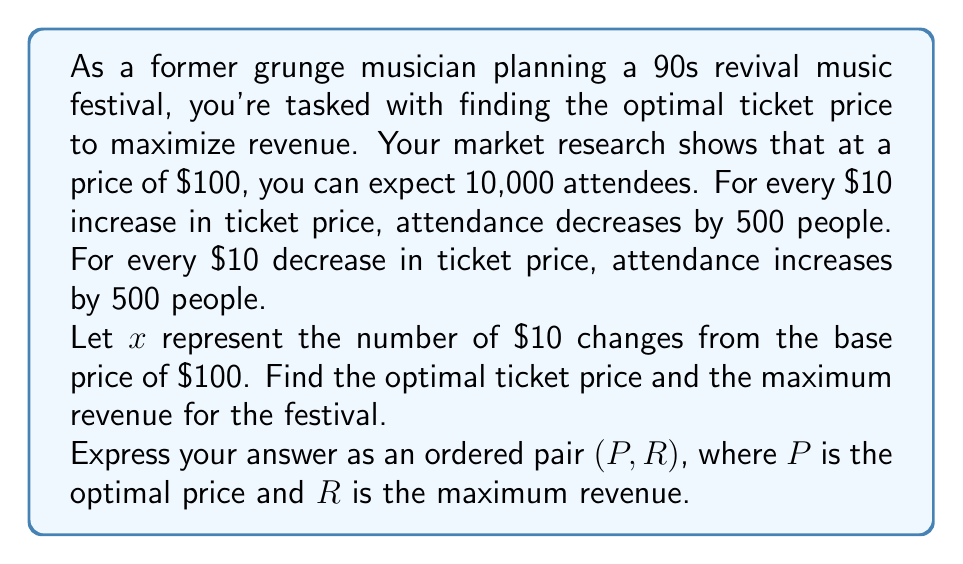Can you answer this question? Let's approach this step-by-step:

1) First, let's define our variables:
   $x$ = number of $10 changes from the base price (positive for increases, negative for decreases)
   $P$ = ticket price
   $A$ = attendance
   $R$ = revenue

2) We can express the price as a function of $x$:
   $P = 100 + 10x$

3) We can express attendance as a function of $x$:
   $A = 10000 - 500x$

4) Revenue is price times attendance:
   $R = P \cdot A = (100 + 10x)(10000 - 500x)$

5) Expand this expression:
   $R = 1000000 + 100000x - 50000x - 5000x^2$
   $R = 1000000 + 50000x - 5000x^2$

6) To find the maximum revenue, we need to find where the derivative of $R$ with respect to $x$ is zero:
   $\frac{dR}{dx} = 50000 - 10000x$

7) Set this equal to zero and solve for $x$:
   $50000 - 10000x = 0$
   $x = 5$

8) This critical point will give us the maximum revenue because the parabola opens downward (the coefficient of $x^2$ is negative).

9) Now we can calculate the optimal price:
   $P = 100 + 10(5) = 150$

10) And the maximum revenue:
    $R = 1000000 + 50000(5) - 5000(5^2) = 1125000$

Therefore, the optimal ticket price is $150, and the maximum revenue is $1,125,000.
Answer: $(150, 1125000)$ 